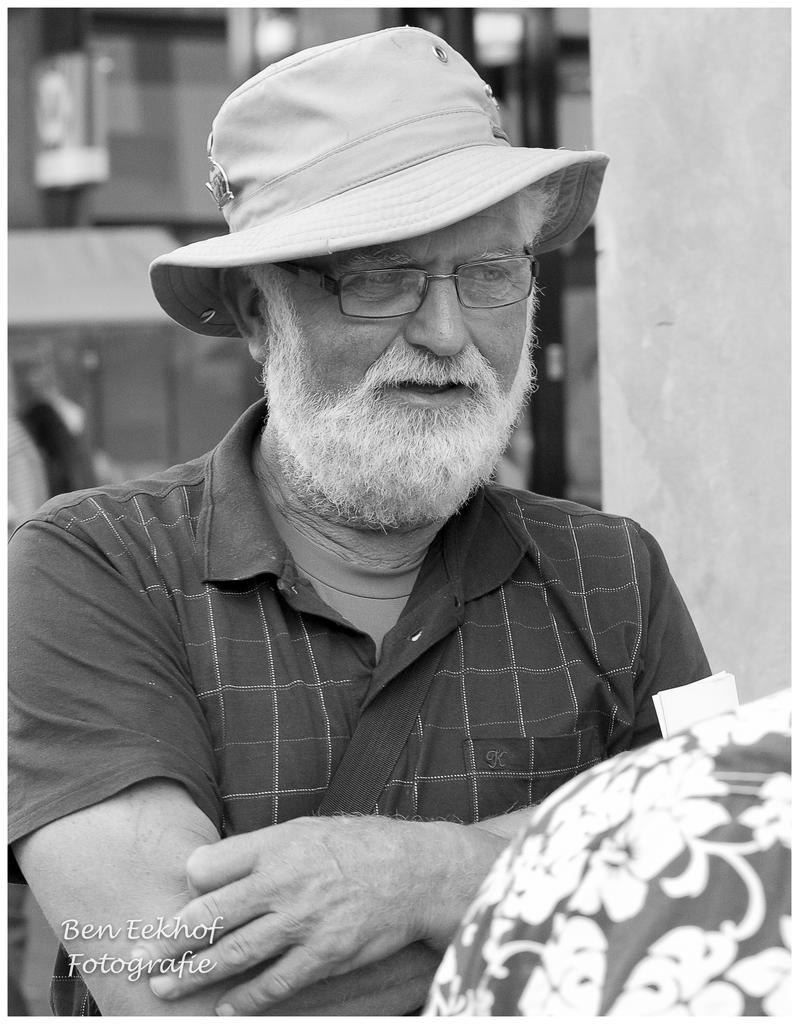What is the color scheme of the image? The image is black and white. Can you describe the person in the image? The person in the image is wearing a hat, spectacles, and a T-shirt. What is the background of the image like? The background of the image is blurry. Is there any additional information or text in the image? Yes, there is a watermark at the bottom left side of the image. What type of fuel is being used by the person in the image? There is no indication of any fuel being used in the image, as it features a person wearing a hat, spectacles, and a T-shirt in a black and white setting with a blurry background and a watermark. Where is the lunchroom located in the image? There is no lunchroom present in the image. 